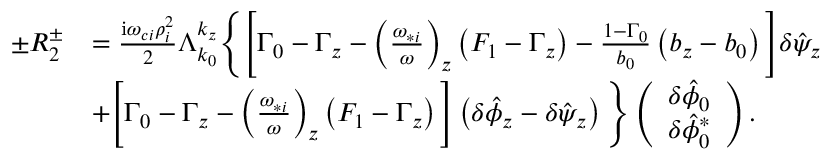<formula> <loc_0><loc_0><loc_500><loc_500>\begin{array} { r l } { \pm R _ { 2 } ^ { \pm } } & { = \frac { i \omega _ { c i } \rho _ { i } ^ { 2 } } { 2 } \Lambda _ { k _ { 0 } } ^ { k _ { z } } \left \{ \left [ \Gamma _ { 0 } - \Gamma _ { z } - \left ( \frac { \omega _ { * i } } { \omega } \right ) _ { z } \left ( F _ { 1 } - \Gamma _ { z } \right ) - \frac { 1 - \Gamma _ { 0 } } { b _ { 0 } } \left ( b _ { z } - b _ { 0 } \right ) \right ] \delta \hat { \psi } _ { z } } \\ & { + \left [ \Gamma _ { 0 } - \Gamma _ { z } - \left ( \frac { \omega _ { * i } } { \omega } \right ) _ { z } \left ( F _ { 1 } - \Gamma _ { z } \right ) \right ] \left ( \delta \hat { \phi } _ { z } - \delta \hat { \psi } _ { z } \right ) \right \} \left ( \begin{array} { c } { \delta \hat { \phi } _ { 0 } } \\ { \delta \hat { \phi } _ { 0 } ^ { * } } \end{array} \right ) . } \end{array}</formula> 